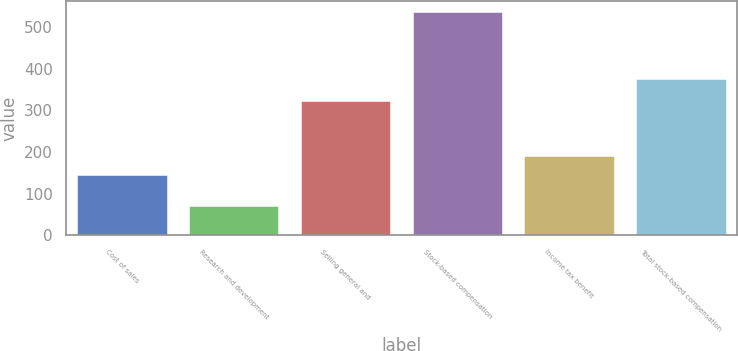<chart> <loc_0><loc_0><loc_500><loc_500><bar_chart><fcel>Cost of sales<fcel>Research and development<fcel>Selling general and<fcel>Stock-based compensation<fcel>Income tax benefit<fcel>Total stock-based compensation<nl><fcel>144<fcel>70<fcel>322<fcel>536<fcel>190.6<fcel>376<nl></chart> 